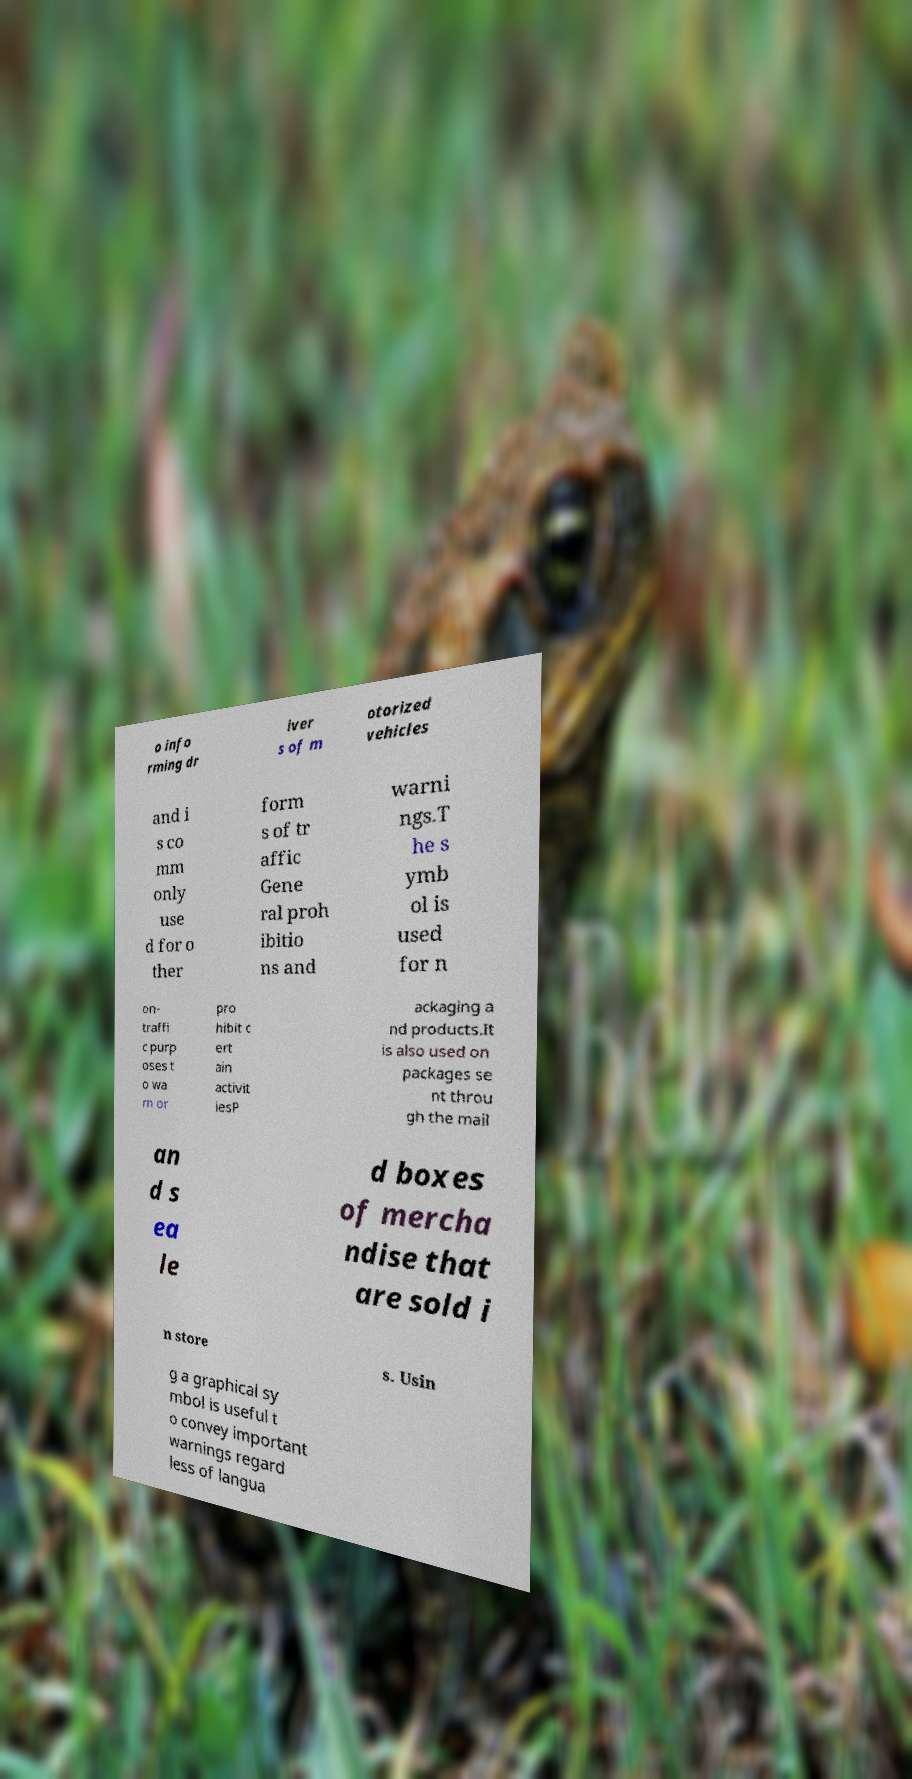Please identify and transcribe the text found in this image. o info rming dr iver s of m otorized vehicles and i s co mm only use d for o ther form s of tr affic Gene ral proh ibitio ns and warni ngs.T he s ymb ol is used for n on- traffi c purp oses t o wa rn or pro hibit c ert ain activit iesP ackaging a nd products.It is also used on packages se nt throu gh the mail an d s ea le d boxes of mercha ndise that are sold i n store s. Usin g a graphical sy mbol is useful t o convey important warnings regard less of langua 